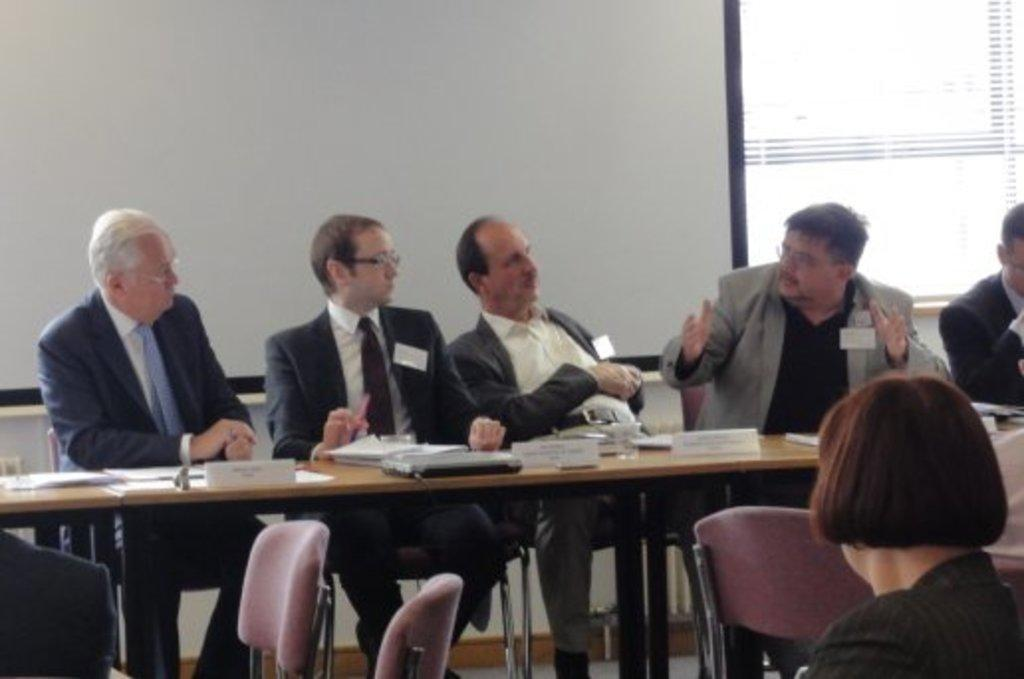How many people are in the image? There is a group of people in the image. What are the people doing in the image? The people are sitting in front of a table. What items can be seen on the table? There are glasses and papers on the table. What is visible in the background of the image? There is a board and a window in the background of the image. What type of wood can be seen on the side of the table in the image? There is no specific type of wood mentioned or visible on the side of the table in the image. How many kittens are sitting on the table with the people in the image? There are no kittens present in the image; it only features a group of people, glasses, and papers on the table. 